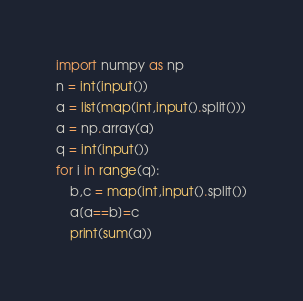Convert code to text. <code><loc_0><loc_0><loc_500><loc_500><_Python_>import numpy as np
n = int(input())
a = list(map(int,input().split()))
a = np.array(a)
q = int(input())
for i in range(q):
    b,c = map(int,input().split())
    a[a==b]=c
    print(sum(a))</code> 